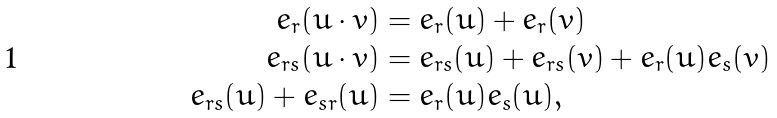<formula> <loc_0><loc_0><loc_500><loc_500>e _ { r } ( u \cdot v ) & = e _ { r } ( u ) + e _ { r } ( v ) \\ e _ { r s } ( u \cdot v ) & = e _ { r s } ( u ) + e _ { r s } ( v ) + e _ { r } ( u ) e _ { s } ( v ) \\ e _ { r s } ( u ) + e _ { s r } ( u ) & = e _ { r } ( u ) e _ { s } ( u ) ,</formula> 